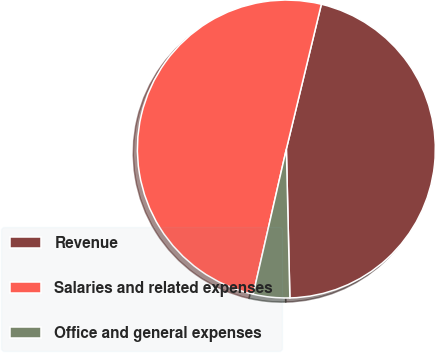Convert chart to OTSL. <chart><loc_0><loc_0><loc_500><loc_500><pie_chart><fcel>Revenue<fcel>Salaries and related expenses<fcel>Office and general expenses<nl><fcel>45.85%<fcel>50.2%<fcel>3.95%<nl></chart> 